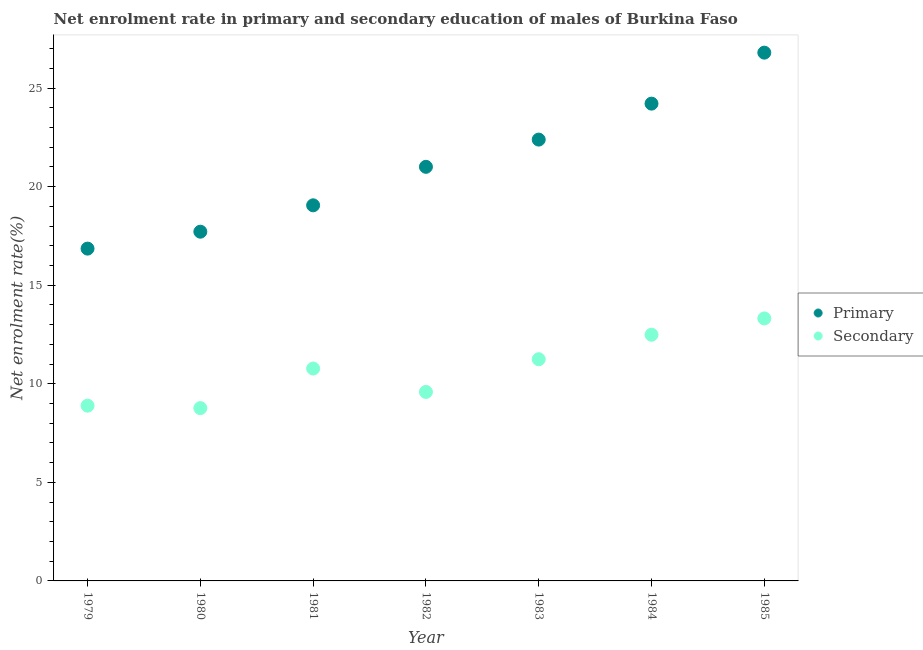How many different coloured dotlines are there?
Your answer should be compact. 2. What is the enrollment rate in primary education in 1982?
Make the answer very short. 21.01. Across all years, what is the maximum enrollment rate in secondary education?
Your response must be concise. 13.31. Across all years, what is the minimum enrollment rate in primary education?
Provide a short and direct response. 16.86. In which year was the enrollment rate in primary education minimum?
Ensure brevity in your answer.  1979. What is the total enrollment rate in primary education in the graph?
Offer a terse response. 148.02. What is the difference between the enrollment rate in primary education in 1982 and that in 1983?
Your response must be concise. -1.38. What is the difference between the enrollment rate in secondary education in 1983 and the enrollment rate in primary education in 1980?
Offer a terse response. -6.47. What is the average enrollment rate in primary education per year?
Ensure brevity in your answer.  21.15. In the year 1980, what is the difference between the enrollment rate in primary education and enrollment rate in secondary education?
Make the answer very short. 8.95. In how many years, is the enrollment rate in primary education greater than 1 %?
Make the answer very short. 7. What is the ratio of the enrollment rate in secondary education in 1981 to that in 1982?
Your response must be concise. 1.12. Is the enrollment rate in primary education in 1980 less than that in 1981?
Provide a short and direct response. Yes. What is the difference between the highest and the second highest enrollment rate in primary education?
Provide a short and direct response. 2.59. What is the difference between the highest and the lowest enrollment rate in secondary education?
Your response must be concise. 4.55. In how many years, is the enrollment rate in primary education greater than the average enrollment rate in primary education taken over all years?
Provide a short and direct response. 3. Is the sum of the enrollment rate in secondary education in 1981 and 1982 greater than the maximum enrollment rate in primary education across all years?
Provide a short and direct response. No. Is the enrollment rate in primary education strictly greater than the enrollment rate in secondary education over the years?
Give a very brief answer. Yes. How many dotlines are there?
Your response must be concise. 2. How many years are there in the graph?
Offer a very short reply. 7. What is the difference between two consecutive major ticks on the Y-axis?
Give a very brief answer. 5. Are the values on the major ticks of Y-axis written in scientific E-notation?
Give a very brief answer. No. Where does the legend appear in the graph?
Offer a terse response. Center right. What is the title of the graph?
Give a very brief answer. Net enrolment rate in primary and secondary education of males of Burkina Faso. What is the label or title of the Y-axis?
Provide a succinct answer. Net enrolment rate(%). What is the Net enrolment rate(%) of Primary in 1979?
Ensure brevity in your answer.  16.86. What is the Net enrolment rate(%) in Secondary in 1979?
Your answer should be compact. 8.89. What is the Net enrolment rate(%) of Primary in 1980?
Your answer should be very brief. 17.71. What is the Net enrolment rate(%) in Secondary in 1980?
Your response must be concise. 8.77. What is the Net enrolment rate(%) of Primary in 1981?
Offer a very short reply. 19.05. What is the Net enrolment rate(%) in Secondary in 1981?
Make the answer very short. 10.77. What is the Net enrolment rate(%) in Primary in 1982?
Ensure brevity in your answer.  21.01. What is the Net enrolment rate(%) of Secondary in 1982?
Your answer should be very brief. 9.59. What is the Net enrolment rate(%) in Primary in 1983?
Give a very brief answer. 22.39. What is the Net enrolment rate(%) of Secondary in 1983?
Make the answer very short. 11.25. What is the Net enrolment rate(%) in Primary in 1984?
Give a very brief answer. 24.21. What is the Net enrolment rate(%) of Secondary in 1984?
Provide a short and direct response. 12.49. What is the Net enrolment rate(%) of Primary in 1985?
Offer a very short reply. 26.8. What is the Net enrolment rate(%) in Secondary in 1985?
Keep it short and to the point. 13.31. Across all years, what is the maximum Net enrolment rate(%) of Primary?
Your response must be concise. 26.8. Across all years, what is the maximum Net enrolment rate(%) in Secondary?
Ensure brevity in your answer.  13.31. Across all years, what is the minimum Net enrolment rate(%) in Primary?
Make the answer very short. 16.86. Across all years, what is the minimum Net enrolment rate(%) of Secondary?
Your answer should be very brief. 8.77. What is the total Net enrolment rate(%) of Primary in the graph?
Provide a short and direct response. 148.02. What is the total Net enrolment rate(%) of Secondary in the graph?
Your answer should be very brief. 75.06. What is the difference between the Net enrolment rate(%) in Primary in 1979 and that in 1980?
Provide a succinct answer. -0.86. What is the difference between the Net enrolment rate(%) of Secondary in 1979 and that in 1980?
Make the answer very short. 0.12. What is the difference between the Net enrolment rate(%) in Primary in 1979 and that in 1981?
Ensure brevity in your answer.  -2.2. What is the difference between the Net enrolment rate(%) in Secondary in 1979 and that in 1981?
Ensure brevity in your answer.  -1.88. What is the difference between the Net enrolment rate(%) of Primary in 1979 and that in 1982?
Your response must be concise. -4.15. What is the difference between the Net enrolment rate(%) of Secondary in 1979 and that in 1982?
Offer a very short reply. -0.7. What is the difference between the Net enrolment rate(%) of Primary in 1979 and that in 1983?
Ensure brevity in your answer.  -5.53. What is the difference between the Net enrolment rate(%) in Secondary in 1979 and that in 1983?
Offer a terse response. -2.36. What is the difference between the Net enrolment rate(%) in Primary in 1979 and that in 1984?
Ensure brevity in your answer.  -7.35. What is the difference between the Net enrolment rate(%) of Secondary in 1979 and that in 1984?
Make the answer very short. -3.6. What is the difference between the Net enrolment rate(%) in Primary in 1979 and that in 1985?
Give a very brief answer. -9.94. What is the difference between the Net enrolment rate(%) of Secondary in 1979 and that in 1985?
Offer a terse response. -4.43. What is the difference between the Net enrolment rate(%) of Primary in 1980 and that in 1981?
Make the answer very short. -1.34. What is the difference between the Net enrolment rate(%) of Secondary in 1980 and that in 1981?
Offer a very short reply. -2.01. What is the difference between the Net enrolment rate(%) of Primary in 1980 and that in 1982?
Ensure brevity in your answer.  -3.29. What is the difference between the Net enrolment rate(%) in Secondary in 1980 and that in 1982?
Offer a very short reply. -0.82. What is the difference between the Net enrolment rate(%) in Primary in 1980 and that in 1983?
Offer a very short reply. -4.67. What is the difference between the Net enrolment rate(%) in Secondary in 1980 and that in 1983?
Provide a succinct answer. -2.48. What is the difference between the Net enrolment rate(%) of Primary in 1980 and that in 1984?
Your answer should be compact. -6.5. What is the difference between the Net enrolment rate(%) in Secondary in 1980 and that in 1984?
Your answer should be very brief. -3.72. What is the difference between the Net enrolment rate(%) of Primary in 1980 and that in 1985?
Keep it short and to the point. -9.08. What is the difference between the Net enrolment rate(%) of Secondary in 1980 and that in 1985?
Offer a terse response. -4.55. What is the difference between the Net enrolment rate(%) in Primary in 1981 and that in 1982?
Your answer should be very brief. -1.95. What is the difference between the Net enrolment rate(%) of Secondary in 1981 and that in 1982?
Offer a terse response. 1.19. What is the difference between the Net enrolment rate(%) in Primary in 1981 and that in 1983?
Keep it short and to the point. -3.33. What is the difference between the Net enrolment rate(%) in Secondary in 1981 and that in 1983?
Offer a terse response. -0.47. What is the difference between the Net enrolment rate(%) of Primary in 1981 and that in 1984?
Offer a very short reply. -5.16. What is the difference between the Net enrolment rate(%) of Secondary in 1981 and that in 1984?
Offer a very short reply. -1.71. What is the difference between the Net enrolment rate(%) of Primary in 1981 and that in 1985?
Your answer should be very brief. -7.74. What is the difference between the Net enrolment rate(%) in Secondary in 1981 and that in 1985?
Your answer should be compact. -2.54. What is the difference between the Net enrolment rate(%) in Primary in 1982 and that in 1983?
Give a very brief answer. -1.38. What is the difference between the Net enrolment rate(%) in Secondary in 1982 and that in 1983?
Your answer should be very brief. -1.66. What is the difference between the Net enrolment rate(%) in Primary in 1982 and that in 1984?
Make the answer very short. -3.21. What is the difference between the Net enrolment rate(%) of Secondary in 1982 and that in 1984?
Keep it short and to the point. -2.9. What is the difference between the Net enrolment rate(%) in Primary in 1982 and that in 1985?
Your response must be concise. -5.79. What is the difference between the Net enrolment rate(%) in Secondary in 1982 and that in 1985?
Provide a short and direct response. -3.73. What is the difference between the Net enrolment rate(%) in Primary in 1983 and that in 1984?
Keep it short and to the point. -1.82. What is the difference between the Net enrolment rate(%) in Secondary in 1983 and that in 1984?
Your answer should be very brief. -1.24. What is the difference between the Net enrolment rate(%) of Primary in 1983 and that in 1985?
Keep it short and to the point. -4.41. What is the difference between the Net enrolment rate(%) in Secondary in 1983 and that in 1985?
Keep it short and to the point. -2.07. What is the difference between the Net enrolment rate(%) of Primary in 1984 and that in 1985?
Your answer should be compact. -2.59. What is the difference between the Net enrolment rate(%) in Secondary in 1984 and that in 1985?
Ensure brevity in your answer.  -0.83. What is the difference between the Net enrolment rate(%) of Primary in 1979 and the Net enrolment rate(%) of Secondary in 1980?
Ensure brevity in your answer.  8.09. What is the difference between the Net enrolment rate(%) of Primary in 1979 and the Net enrolment rate(%) of Secondary in 1981?
Keep it short and to the point. 6.08. What is the difference between the Net enrolment rate(%) of Primary in 1979 and the Net enrolment rate(%) of Secondary in 1982?
Keep it short and to the point. 7.27. What is the difference between the Net enrolment rate(%) in Primary in 1979 and the Net enrolment rate(%) in Secondary in 1983?
Provide a short and direct response. 5.61. What is the difference between the Net enrolment rate(%) in Primary in 1979 and the Net enrolment rate(%) in Secondary in 1984?
Your answer should be very brief. 4.37. What is the difference between the Net enrolment rate(%) in Primary in 1979 and the Net enrolment rate(%) in Secondary in 1985?
Give a very brief answer. 3.54. What is the difference between the Net enrolment rate(%) of Primary in 1980 and the Net enrolment rate(%) of Secondary in 1981?
Ensure brevity in your answer.  6.94. What is the difference between the Net enrolment rate(%) in Primary in 1980 and the Net enrolment rate(%) in Secondary in 1982?
Ensure brevity in your answer.  8.13. What is the difference between the Net enrolment rate(%) of Primary in 1980 and the Net enrolment rate(%) of Secondary in 1983?
Provide a succinct answer. 6.47. What is the difference between the Net enrolment rate(%) of Primary in 1980 and the Net enrolment rate(%) of Secondary in 1984?
Ensure brevity in your answer.  5.23. What is the difference between the Net enrolment rate(%) of Primary in 1980 and the Net enrolment rate(%) of Secondary in 1985?
Offer a very short reply. 4.4. What is the difference between the Net enrolment rate(%) of Primary in 1981 and the Net enrolment rate(%) of Secondary in 1982?
Offer a terse response. 9.47. What is the difference between the Net enrolment rate(%) of Primary in 1981 and the Net enrolment rate(%) of Secondary in 1983?
Provide a succinct answer. 7.81. What is the difference between the Net enrolment rate(%) of Primary in 1981 and the Net enrolment rate(%) of Secondary in 1984?
Your answer should be very brief. 6.57. What is the difference between the Net enrolment rate(%) in Primary in 1981 and the Net enrolment rate(%) in Secondary in 1985?
Offer a terse response. 5.74. What is the difference between the Net enrolment rate(%) of Primary in 1982 and the Net enrolment rate(%) of Secondary in 1983?
Provide a short and direct response. 9.76. What is the difference between the Net enrolment rate(%) in Primary in 1982 and the Net enrolment rate(%) in Secondary in 1984?
Make the answer very short. 8.52. What is the difference between the Net enrolment rate(%) in Primary in 1982 and the Net enrolment rate(%) in Secondary in 1985?
Keep it short and to the point. 7.69. What is the difference between the Net enrolment rate(%) in Primary in 1983 and the Net enrolment rate(%) in Secondary in 1984?
Your response must be concise. 9.9. What is the difference between the Net enrolment rate(%) in Primary in 1983 and the Net enrolment rate(%) in Secondary in 1985?
Provide a succinct answer. 9.07. What is the difference between the Net enrolment rate(%) of Primary in 1984 and the Net enrolment rate(%) of Secondary in 1985?
Your answer should be compact. 10.9. What is the average Net enrolment rate(%) of Primary per year?
Your response must be concise. 21.15. What is the average Net enrolment rate(%) in Secondary per year?
Offer a very short reply. 10.72. In the year 1979, what is the difference between the Net enrolment rate(%) of Primary and Net enrolment rate(%) of Secondary?
Provide a succinct answer. 7.97. In the year 1980, what is the difference between the Net enrolment rate(%) in Primary and Net enrolment rate(%) in Secondary?
Make the answer very short. 8.95. In the year 1981, what is the difference between the Net enrolment rate(%) in Primary and Net enrolment rate(%) in Secondary?
Provide a succinct answer. 8.28. In the year 1982, what is the difference between the Net enrolment rate(%) of Primary and Net enrolment rate(%) of Secondary?
Keep it short and to the point. 11.42. In the year 1983, what is the difference between the Net enrolment rate(%) in Primary and Net enrolment rate(%) in Secondary?
Provide a short and direct response. 11.14. In the year 1984, what is the difference between the Net enrolment rate(%) in Primary and Net enrolment rate(%) in Secondary?
Make the answer very short. 11.72. In the year 1985, what is the difference between the Net enrolment rate(%) of Primary and Net enrolment rate(%) of Secondary?
Provide a short and direct response. 13.48. What is the ratio of the Net enrolment rate(%) in Primary in 1979 to that in 1980?
Make the answer very short. 0.95. What is the ratio of the Net enrolment rate(%) of Secondary in 1979 to that in 1980?
Your response must be concise. 1.01. What is the ratio of the Net enrolment rate(%) of Primary in 1979 to that in 1981?
Ensure brevity in your answer.  0.88. What is the ratio of the Net enrolment rate(%) in Secondary in 1979 to that in 1981?
Offer a very short reply. 0.83. What is the ratio of the Net enrolment rate(%) in Primary in 1979 to that in 1982?
Make the answer very short. 0.8. What is the ratio of the Net enrolment rate(%) in Secondary in 1979 to that in 1982?
Ensure brevity in your answer.  0.93. What is the ratio of the Net enrolment rate(%) of Primary in 1979 to that in 1983?
Offer a terse response. 0.75. What is the ratio of the Net enrolment rate(%) of Secondary in 1979 to that in 1983?
Give a very brief answer. 0.79. What is the ratio of the Net enrolment rate(%) in Primary in 1979 to that in 1984?
Provide a short and direct response. 0.7. What is the ratio of the Net enrolment rate(%) of Secondary in 1979 to that in 1984?
Make the answer very short. 0.71. What is the ratio of the Net enrolment rate(%) of Primary in 1979 to that in 1985?
Your answer should be compact. 0.63. What is the ratio of the Net enrolment rate(%) in Secondary in 1979 to that in 1985?
Provide a short and direct response. 0.67. What is the ratio of the Net enrolment rate(%) in Primary in 1980 to that in 1981?
Your response must be concise. 0.93. What is the ratio of the Net enrolment rate(%) of Secondary in 1980 to that in 1981?
Offer a very short reply. 0.81. What is the ratio of the Net enrolment rate(%) of Primary in 1980 to that in 1982?
Your answer should be compact. 0.84. What is the ratio of the Net enrolment rate(%) of Secondary in 1980 to that in 1982?
Your answer should be compact. 0.91. What is the ratio of the Net enrolment rate(%) of Primary in 1980 to that in 1983?
Your response must be concise. 0.79. What is the ratio of the Net enrolment rate(%) of Secondary in 1980 to that in 1983?
Your answer should be compact. 0.78. What is the ratio of the Net enrolment rate(%) in Primary in 1980 to that in 1984?
Make the answer very short. 0.73. What is the ratio of the Net enrolment rate(%) in Secondary in 1980 to that in 1984?
Make the answer very short. 0.7. What is the ratio of the Net enrolment rate(%) of Primary in 1980 to that in 1985?
Offer a terse response. 0.66. What is the ratio of the Net enrolment rate(%) of Secondary in 1980 to that in 1985?
Give a very brief answer. 0.66. What is the ratio of the Net enrolment rate(%) in Primary in 1981 to that in 1982?
Provide a succinct answer. 0.91. What is the ratio of the Net enrolment rate(%) in Secondary in 1981 to that in 1982?
Offer a terse response. 1.12. What is the ratio of the Net enrolment rate(%) of Primary in 1981 to that in 1983?
Make the answer very short. 0.85. What is the ratio of the Net enrolment rate(%) in Secondary in 1981 to that in 1983?
Make the answer very short. 0.96. What is the ratio of the Net enrolment rate(%) in Primary in 1981 to that in 1984?
Provide a succinct answer. 0.79. What is the ratio of the Net enrolment rate(%) of Secondary in 1981 to that in 1984?
Provide a short and direct response. 0.86. What is the ratio of the Net enrolment rate(%) of Primary in 1981 to that in 1985?
Ensure brevity in your answer.  0.71. What is the ratio of the Net enrolment rate(%) in Secondary in 1981 to that in 1985?
Provide a short and direct response. 0.81. What is the ratio of the Net enrolment rate(%) of Primary in 1982 to that in 1983?
Your answer should be very brief. 0.94. What is the ratio of the Net enrolment rate(%) of Secondary in 1982 to that in 1983?
Your response must be concise. 0.85. What is the ratio of the Net enrolment rate(%) in Primary in 1982 to that in 1984?
Offer a very short reply. 0.87. What is the ratio of the Net enrolment rate(%) in Secondary in 1982 to that in 1984?
Provide a succinct answer. 0.77. What is the ratio of the Net enrolment rate(%) of Primary in 1982 to that in 1985?
Provide a short and direct response. 0.78. What is the ratio of the Net enrolment rate(%) in Secondary in 1982 to that in 1985?
Make the answer very short. 0.72. What is the ratio of the Net enrolment rate(%) of Primary in 1983 to that in 1984?
Make the answer very short. 0.92. What is the ratio of the Net enrolment rate(%) in Secondary in 1983 to that in 1984?
Offer a very short reply. 0.9. What is the ratio of the Net enrolment rate(%) of Primary in 1983 to that in 1985?
Make the answer very short. 0.84. What is the ratio of the Net enrolment rate(%) of Secondary in 1983 to that in 1985?
Ensure brevity in your answer.  0.84. What is the ratio of the Net enrolment rate(%) in Primary in 1984 to that in 1985?
Offer a terse response. 0.9. What is the ratio of the Net enrolment rate(%) of Secondary in 1984 to that in 1985?
Your answer should be compact. 0.94. What is the difference between the highest and the second highest Net enrolment rate(%) of Primary?
Your response must be concise. 2.59. What is the difference between the highest and the second highest Net enrolment rate(%) of Secondary?
Provide a short and direct response. 0.83. What is the difference between the highest and the lowest Net enrolment rate(%) of Primary?
Make the answer very short. 9.94. What is the difference between the highest and the lowest Net enrolment rate(%) in Secondary?
Give a very brief answer. 4.55. 